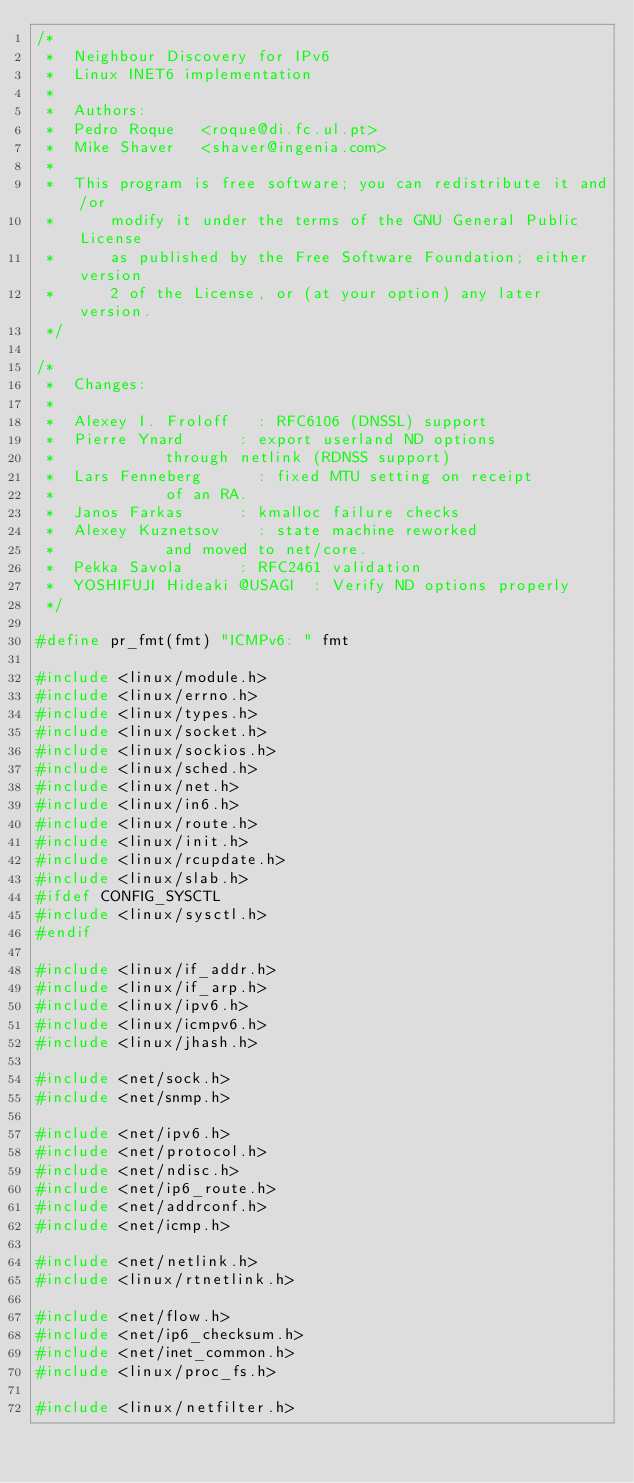Convert code to text. <code><loc_0><loc_0><loc_500><loc_500><_C_>/*
 *	Neighbour Discovery for IPv6
 *	Linux INET6 implementation
 *
 *	Authors:
 *	Pedro Roque		<roque@di.fc.ul.pt>
 *	Mike Shaver		<shaver@ingenia.com>
 *
 *	This program is free software; you can redistribute it and/or
 *      modify it under the terms of the GNU General Public License
 *      as published by the Free Software Foundation; either version
 *      2 of the License, or (at your option) any later version.
 */

/*
 *	Changes:
 *
 *	Alexey I. Froloff		:	RFC6106 (DNSSL) support
 *	Pierre Ynard			:	export userland ND options
 *						through netlink (RDNSS support)
 *	Lars Fenneberg			:	fixed MTU setting on receipt
 *						of an RA.
 *	Janos Farkas			:	kmalloc failure checks
 *	Alexey Kuznetsov		:	state machine reworked
 *						and moved to net/core.
 *	Pekka Savola			:	RFC2461 validation
 *	YOSHIFUJI Hideaki @USAGI	:	Verify ND options properly
 */

#define pr_fmt(fmt) "ICMPv6: " fmt

#include <linux/module.h>
#include <linux/errno.h>
#include <linux/types.h>
#include <linux/socket.h>
#include <linux/sockios.h>
#include <linux/sched.h>
#include <linux/net.h>
#include <linux/in6.h>
#include <linux/route.h>
#include <linux/init.h>
#include <linux/rcupdate.h>
#include <linux/slab.h>
#ifdef CONFIG_SYSCTL
#include <linux/sysctl.h>
#endif

#include <linux/if_addr.h>
#include <linux/if_arp.h>
#include <linux/ipv6.h>
#include <linux/icmpv6.h>
#include <linux/jhash.h>

#include <net/sock.h>
#include <net/snmp.h>

#include <net/ipv6.h>
#include <net/protocol.h>
#include <net/ndisc.h>
#include <net/ip6_route.h>
#include <net/addrconf.h>
#include <net/icmp.h>

#include <net/netlink.h>
#include <linux/rtnetlink.h>

#include <net/flow.h>
#include <net/ip6_checksum.h>
#include <net/inet_common.h>
#include <linux/proc_fs.h>

#include <linux/netfilter.h></code> 